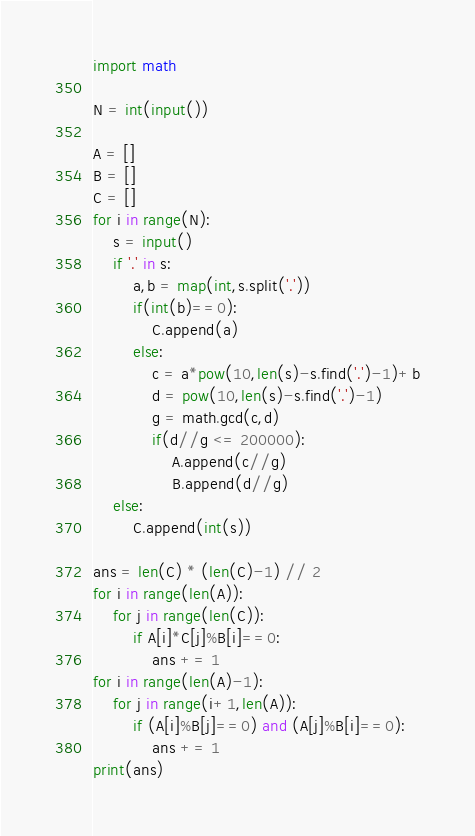Convert code to text. <code><loc_0><loc_0><loc_500><loc_500><_Python_>import math

N = int(input())

A = []
B = []
C = []
for i in range(N):
    s = input()
    if '.' in s:
        a,b = map(int,s.split('.'))
        if(int(b)==0):
            C.append(a)
        else:
            c = a*pow(10,len(s)-s.find('.')-1)+b
            d = pow(10,len(s)-s.find('.')-1)
            g = math.gcd(c,d)
            if(d//g <= 200000):
                A.append(c//g)
                B.append(d//g)
    else:
        C.append(int(s))

ans = len(C) * (len(C)-1) // 2
for i in range(len(A)):
    for j in range(len(C)):
        if A[i]*C[j]%B[i]==0:
            ans += 1
for i in range(len(A)-1):
    for j in range(i+1,len(A)):
        if (A[i]%B[j]==0) and (A[j]%B[i]==0):
            ans += 1
print(ans)
</code> 